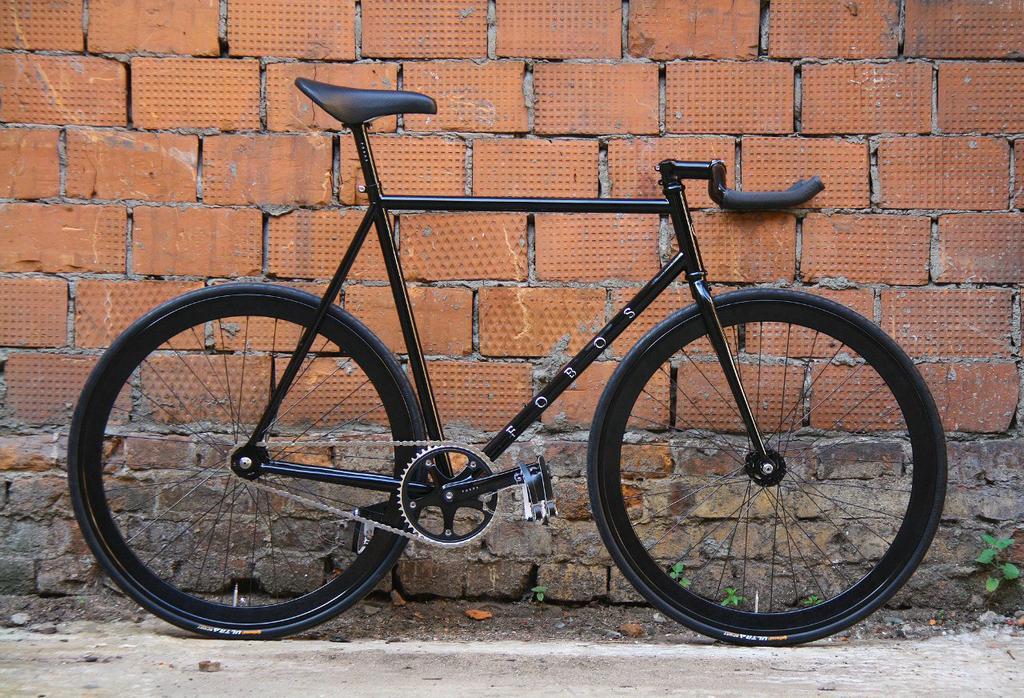Describe this image in one or two sentences. In this image I can see the bicycle which is in black color. To the side of the bicycle I can see the brown color brick wall. I can also see some plants to the side. 